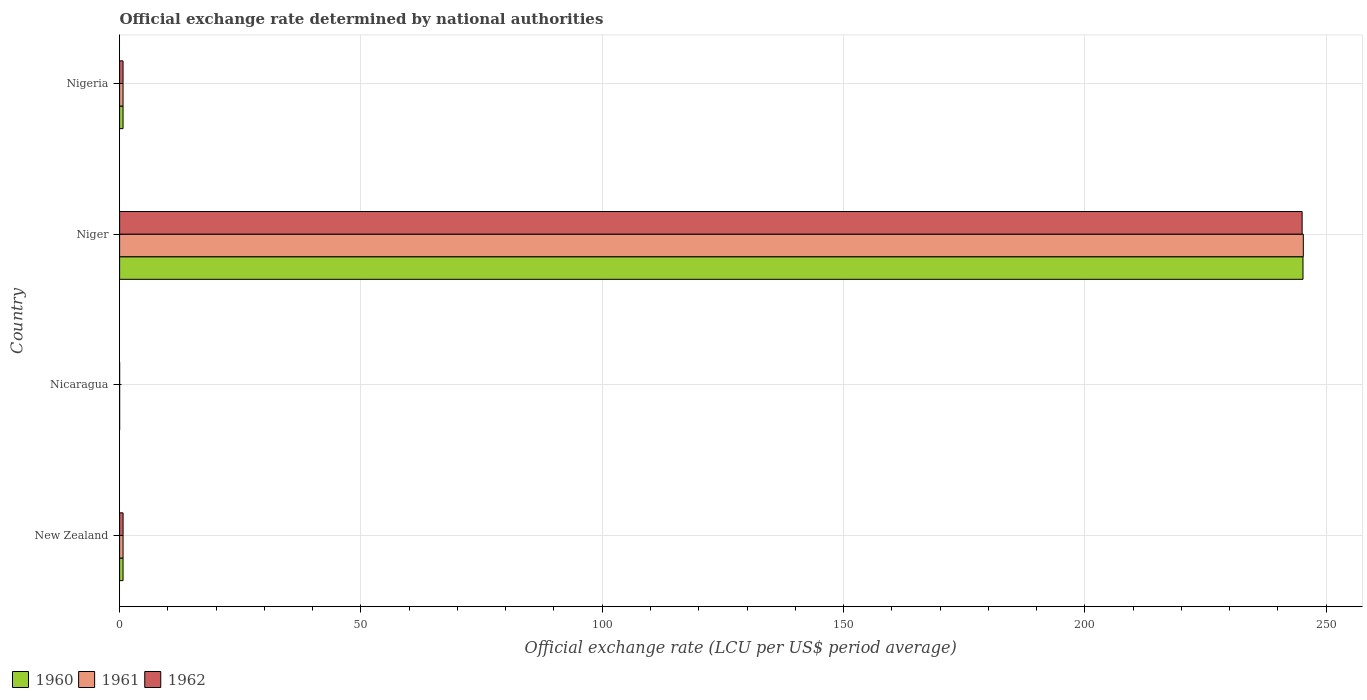How many different coloured bars are there?
Provide a succinct answer. 3. What is the label of the 1st group of bars from the top?
Ensure brevity in your answer.  Nigeria. In how many cases, is the number of bars for a given country not equal to the number of legend labels?
Offer a terse response. 0. What is the official exchange rate in 1962 in Nicaragua?
Give a very brief answer. 2.060644189655169e-9. Across all countries, what is the maximum official exchange rate in 1961?
Offer a terse response. 245.26. Across all countries, what is the minimum official exchange rate in 1960?
Your answer should be compact. 2.060644189655169e-9. In which country was the official exchange rate in 1960 maximum?
Your response must be concise. Niger. In which country was the official exchange rate in 1960 minimum?
Provide a succinct answer. Nicaragua. What is the total official exchange rate in 1961 in the graph?
Keep it short and to the point. 246.69. What is the difference between the official exchange rate in 1961 in Nicaragua and that in Niger?
Make the answer very short. -245.26. What is the difference between the official exchange rate in 1962 in Nicaragua and the official exchange rate in 1960 in Niger?
Your response must be concise. -245.2. What is the average official exchange rate in 1960 per country?
Offer a very short reply. 61.66. What is the difference between the official exchange rate in 1961 and official exchange rate in 1960 in Nicaragua?
Make the answer very short. 0. What is the ratio of the official exchange rate in 1961 in Nicaragua to that in Nigeria?
Provide a succinct answer. 2.884900712710911e-9. Is the official exchange rate in 1962 in New Zealand less than that in Nicaragua?
Give a very brief answer. No. What is the difference between the highest and the second highest official exchange rate in 1961?
Keep it short and to the point. 244.54. What is the difference between the highest and the lowest official exchange rate in 1962?
Ensure brevity in your answer.  245.01. In how many countries, is the official exchange rate in 1962 greater than the average official exchange rate in 1962 taken over all countries?
Keep it short and to the point. 1. Is the sum of the official exchange rate in 1961 in New Zealand and Nigeria greater than the maximum official exchange rate in 1962 across all countries?
Provide a short and direct response. No. What does the 3rd bar from the top in Nigeria represents?
Your response must be concise. 1960. What does the 1st bar from the bottom in Nigeria represents?
Offer a very short reply. 1960. Are all the bars in the graph horizontal?
Offer a terse response. Yes. Are the values on the major ticks of X-axis written in scientific E-notation?
Make the answer very short. No. Does the graph contain any zero values?
Make the answer very short. No. Does the graph contain grids?
Offer a terse response. Yes. Where does the legend appear in the graph?
Your response must be concise. Bottom left. What is the title of the graph?
Provide a succinct answer. Official exchange rate determined by national authorities. What is the label or title of the X-axis?
Ensure brevity in your answer.  Official exchange rate (LCU per US$ period average). What is the label or title of the Y-axis?
Offer a very short reply. Country. What is the Official exchange rate (LCU per US$ period average) in 1960 in New Zealand?
Your response must be concise. 0.71. What is the Official exchange rate (LCU per US$ period average) of 1961 in New Zealand?
Offer a very short reply. 0.72. What is the Official exchange rate (LCU per US$ period average) of 1962 in New Zealand?
Ensure brevity in your answer.  0.72. What is the Official exchange rate (LCU per US$ period average) of 1960 in Nicaragua?
Offer a terse response. 2.060644189655169e-9. What is the Official exchange rate (LCU per US$ period average) of 1961 in Nicaragua?
Keep it short and to the point. 2.060644189655169e-9. What is the Official exchange rate (LCU per US$ period average) in 1962 in Nicaragua?
Your answer should be very brief. 2.060644189655169e-9. What is the Official exchange rate (LCU per US$ period average) of 1960 in Niger?
Offer a terse response. 245.2. What is the Official exchange rate (LCU per US$ period average) in 1961 in Niger?
Your answer should be compact. 245.26. What is the Official exchange rate (LCU per US$ period average) of 1962 in Niger?
Your answer should be very brief. 245.01. What is the Official exchange rate (LCU per US$ period average) in 1960 in Nigeria?
Make the answer very short. 0.71. What is the Official exchange rate (LCU per US$ period average) in 1961 in Nigeria?
Make the answer very short. 0.71. What is the Official exchange rate (LCU per US$ period average) in 1962 in Nigeria?
Make the answer very short. 0.71. Across all countries, what is the maximum Official exchange rate (LCU per US$ period average) of 1960?
Offer a very short reply. 245.2. Across all countries, what is the maximum Official exchange rate (LCU per US$ period average) of 1961?
Make the answer very short. 245.26. Across all countries, what is the maximum Official exchange rate (LCU per US$ period average) of 1962?
Provide a short and direct response. 245.01. Across all countries, what is the minimum Official exchange rate (LCU per US$ period average) in 1960?
Your answer should be very brief. 2.060644189655169e-9. Across all countries, what is the minimum Official exchange rate (LCU per US$ period average) in 1961?
Provide a succinct answer. 2.060644189655169e-9. Across all countries, what is the minimum Official exchange rate (LCU per US$ period average) of 1962?
Offer a very short reply. 2.060644189655169e-9. What is the total Official exchange rate (LCU per US$ period average) in 1960 in the graph?
Offer a very short reply. 246.62. What is the total Official exchange rate (LCU per US$ period average) in 1961 in the graph?
Offer a very short reply. 246.69. What is the total Official exchange rate (LCU per US$ period average) of 1962 in the graph?
Provide a short and direct response. 246.45. What is the difference between the Official exchange rate (LCU per US$ period average) of 1961 in New Zealand and that in Nicaragua?
Give a very brief answer. 0.72. What is the difference between the Official exchange rate (LCU per US$ period average) of 1962 in New Zealand and that in Nicaragua?
Give a very brief answer. 0.72. What is the difference between the Official exchange rate (LCU per US$ period average) of 1960 in New Zealand and that in Niger?
Make the answer very short. -244.48. What is the difference between the Official exchange rate (LCU per US$ period average) in 1961 in New Zealand and that in Niger?
Offer a very short reply. -244.54. What is the difference between the Official exchange rate (LCU per US$ period average) of 1962 in New Zealand and that in Niger?
Offer a terse response. -244.29. What is the difference between the Official exchange rate (LCU per US$ period average) of 1961 in New Zealand and that in Nigeria?
Your answer should be very brief. 0. What is the difference between the Official exchange rate (LCU per US$ period average) in 1962 in New Zealand and that in Nigeria?
Provide a succinct answer. 0. What is the difference between the Official exchange rate (LCU per US$ period average) of 1960 in Nicaragua and that in Niger?
Offer a very short reply. -245.2. What is the difference between the Official exchange rate (LCU per US$ period average) of 1961 in Nicaragua and that in Niger?
Offer a terse response. -245.26. What is the difference between the Official exchange rate (LCU per US$ period average) of 1962 in Nicaragua and that in Niger?
Keep it short and to the point. -245.01. What is the difference between the Official exchange rate (LCU per US$ period average) of 1960 in Nicaragua and that in Nigeria?
Ensure brevity in your answer.  -0.71. What is the difference between the Official exchange rate (LCU per US$ period average) of 1961 in Nicaragua and that in Nigeria?
Keep it short and to the point. -0.71. What is the difference between the Official exchange rate (LCU per US$ period average) of 1962 in Nicaragua and that in Nigeria?
Offer a very short reply. -0.71. What is the difference between the Official exchange rate (LCU per US$ period average) in 1960 in Niger and that in Nigeria?
Offer a very short reply. 244.48. What is the difference between the Official exchange rate (LCU per US$ period average) in 1961 in Niger and that in Nigeria?
Offer a terse response. 244.55. What is the difference between the Official exchange rate (LCU per US$ period average) of 1962 in Niger and that in Nigeria?
Your answer should be compact. 244.3. What is the difference between the Official exchange rate (LCU per US$ period average) in 1960 in New Zealand and the Official exchange rate (LCU per US$ period average) in 1961 in Nicaragua?
Your answer should be compact. 0.71. What is the difference between the Official exchange rate (LCU per US$ period average) in 1961 in New Zealand and the Official exchange rate (LCU per US$ period average) in 1962 in Nicaragua?
Keep it short and to the point. 0.72. What is the difference between the Official exchange rate (LCU per US$ period average) in 1960 in New Zealand and the Official exchange rate (LCU per US$ period average) in 1961 in Niger?
Your response must be concise. -244.55. What is the difference between the Official exchange rate (LCU per US$ period average) in 1960 in New Zealand and the Official exchange rate (LCU per US$ period average) in 1962 in Niger?
Offer a terse response. -244.3. What is the difference between the Official exchange rate (LCU per US$ period average) in 1961 in New Zealand and the Official exchange rate (LCU per US$ period average) in 1962 in Niger?
Your answer should be very brief. -244.3. What is the difference between the Official exchange rate (LCU per US$ period average) in 1960 in New Zealand and the Official exchange rate (LCU per US$ period average) in 1961 in Nigeria?
Keep it short and to the point. 0. What is the difference between the Official exchange rate (LCU per US$ period average) in 1960 in New Zealand and the Official exchange rate (LCU per US$ period average) in 1962 in Nigeria?
Give a very brief answer. 0. What is the difference between the Official exchange rate (LCU per US$ period average) of 1961 in New Zealand and the Official exchange rate (LCU per US$ period average) of 1962 in Nigeria?
Provide a succinct answer. 0. What is the difference between the Official exchange rate (LCU per US$ period average) in 1960 in Nicaragua and the Official exchange rate (LCU per US$ period average) in 1961 in Niger?
Give a very brief answer. -245.26. What is the difference between the Official exchange rate (LCU per US$ period average) in 1960 in Nicaragua and the Official exchange rate (LCU per US$ period average) in 1962 in Niger?
Offer a terse response. -245.01. What is the difference between the Official exchange rate (LCU per US$ period average) in 1961 in Nicaragua and the Official exchange rate (LCU per US$ period average) in 1962 in Niger?
Provide a succinct answer. -245.01. What is the difference between the Official exchange rate (LCU per US$ period average) in 1960 in Nicaragua and the Official exchange rate (LCU per US$ period average) in 1961 in Nigeria?
Provide a short and direct response. -0.71. What is the difference between the Official exchange rate (LCU per US$ period average) in 1960 in Nicaragua and the Official exchange rate (LCU per US$ period average) in 1962 in Nigeria?
Give a very brief answer. -0.71. What is the difference between the Official exchange rate (LCU per US$ period average) in 1961 in Nicaragua and the Official exchange rate (LCU per US$ period average) in 1962 in Nigeria?
Your response must be concise. -0.71. What is the difference between the Official exchange rate (LCU per US$ period average) of 1960 in Niger and the Official exchange rate (LCU per US$ period average) of 1961 in Nigeria?
Give a very brief answer. 244.48. What is the difference between the Official exchange rate (LCU per US$ period average) in 1960 in Niger and the Official exchange rate (LCU per US$ period average) in 1962 in Nigeria?
Give a very brief answer. 244.48. What is the difference between the Official exchange rate (LCU per US$ period average) of 1961 in Niger and the Official exchange rate (LCU per US$ period average) of 1962 in Nigeria?
Provide a short and direct response. 244.55. What is the average Official exchange rate (LCU per US$ period average) of 1960 per country?
Keep it short and to the point. 61.66. What is the average Official exchange rate (LCU per US$ period average) of 1961 per country?
Offer a very short reply. 61.67. What is the average Official exchange rate (LCU per US$ period average) of 1962 per country?
Provide a short and direct response. 61.61. What is the difference between the Official exchange rate (LCU per US$ period average) in 1960 and Official exchange rate (LCU per US$ period average) in 1961 in New Zealand?
Offer a terse response. -0. What is the difference between the Official exchange rate (LCU per US$ period average) of 1960 and Official exchange rate (LCU per US$ period average) of 1962 in New Zealand?
Your answer should be very brief. -0. What is the difference between the Official exchange rate (LCU per US$ period average) of 1961 and Official exchange rate (LCU per US$ period average) of 1962 in New Zealand?
Keep it short and to the point. -0. What is the difference between the Official exchange rate (LCU per US$ period average) in 1960 and Official exchange rate (LCU per US$ period average) in 1961 in Niger?
Make the answer very short. -0.07. What is the difference between the Official exchange rate (LCU per US$ period average) in 1960 and Official exchange rate (LCU per US$ period average) in 1962 in Niger?
Your answer should be very brief. 0.18. What is the difference between the Official exchange rate (LCU per US$ period average) in 1961 and Official exchange rate (LCU per US$ period average) in 1962 in Niger?
Ensure brevity in your answer.  0.25. What is the difference between the Official exchange rate (LCU per US$ period average) of 1960 and Official exchange rate (LCU per US$ period average) of 1961 in Nigeria?
Ensure brevity in your answer.  0. What is the ratio of the Official exchange rate (LCU per US$ period average) in 1960 in New Zealand to that in Nicaragua?
Provide a succinct answer. 3.47e+08. What is the ratio of the Official exchange rate (LCU per US$ period average) in 1961 in New Zealand to that in Nicaragua?
Keep it short and to the point. 3.47e+08. What is the ratio of the Official exchange rate (LCU per US$ period average) of 1962 in New Zealand to that in Nicaragua?
Your answer should be very brief. 3.49e+08. What is the ratio of the Official exchange rate (LCU per US$ period average) of 1960 in New Zealand to that in Niger?
Offer a very short reply. 0. What is the ratio of the Official exchange rate (LCU per US$ period average) in 1961 in New Zealand to that in Niger?
Ensure brevity in your answer.  0. What is the ratio of the Official exchange rate (LCU per US$ period average) in 1962 in New Zealand to that in Niger?
Your response must be concise. 0. What is the ratio of the Official exchange rate (LCU per US$ period average) of 1960 in New Zealand to that in Nigeria?
Provide a succinct answer. 1. What is the ratio of the Official exchange rate (LCU per US$ period average) of 1961 in New Zealand to that in Nigeria?
Your response must be concise. 1. What is the ratio of the Official exchange rate (LCU per US$ period average) of 1961 in Nicaragua to that in Niger?
Offer a very short reply. 0. What is the ratio of the Official exchange rate (LCU per US$ period average) of 1962 in Nicaragua to that in Nigeria?
Give a very brief answer. 0. What is the ratio of the Official exchange rate (LCU per US$ period average) in 1960 in Niger to that in Nigeria?
Your answer should be very brief. 343.27. What is the ratio of the Official exchange rate (LCU per US$ period average) of 1961 in Niger to that in Nigeria?
Give a very brief answer. 343.36. What is the ratio of the Official exchange rate (LCU per US$ period average) of 1962 in Niger to that in Nigeria?
Provide a succinct answer. 343.02. What is the difference between the highest and the second highest Official exchange rate (LCU per US$ period average) in 1960?
Your answer should be compact. 244.48. What is the difference between the highest and the second highest Official exchange rate (LCU per US$ period average) in 1961?
Make the answer very short. 244.54. What is the difference between the highest and the second highest Official exchange rate (LCU per US$ period average) of 1962?
Offer a terse response. 244.29. What is the difference between the highest and the lowest Official exchange rate (LCU per US$ period average) in 1960?
Your response must be concise. 245.2. What is the difference between the highest and the lowest Official exchange rate (LCU per US$ period average) in 1961?
Offer a very short reply. 245.26. What is the difference between the highest and the lowest Official exchange rate (LCU per US$ period average) of 1962?
Provide a succinct answer. 245.01. 